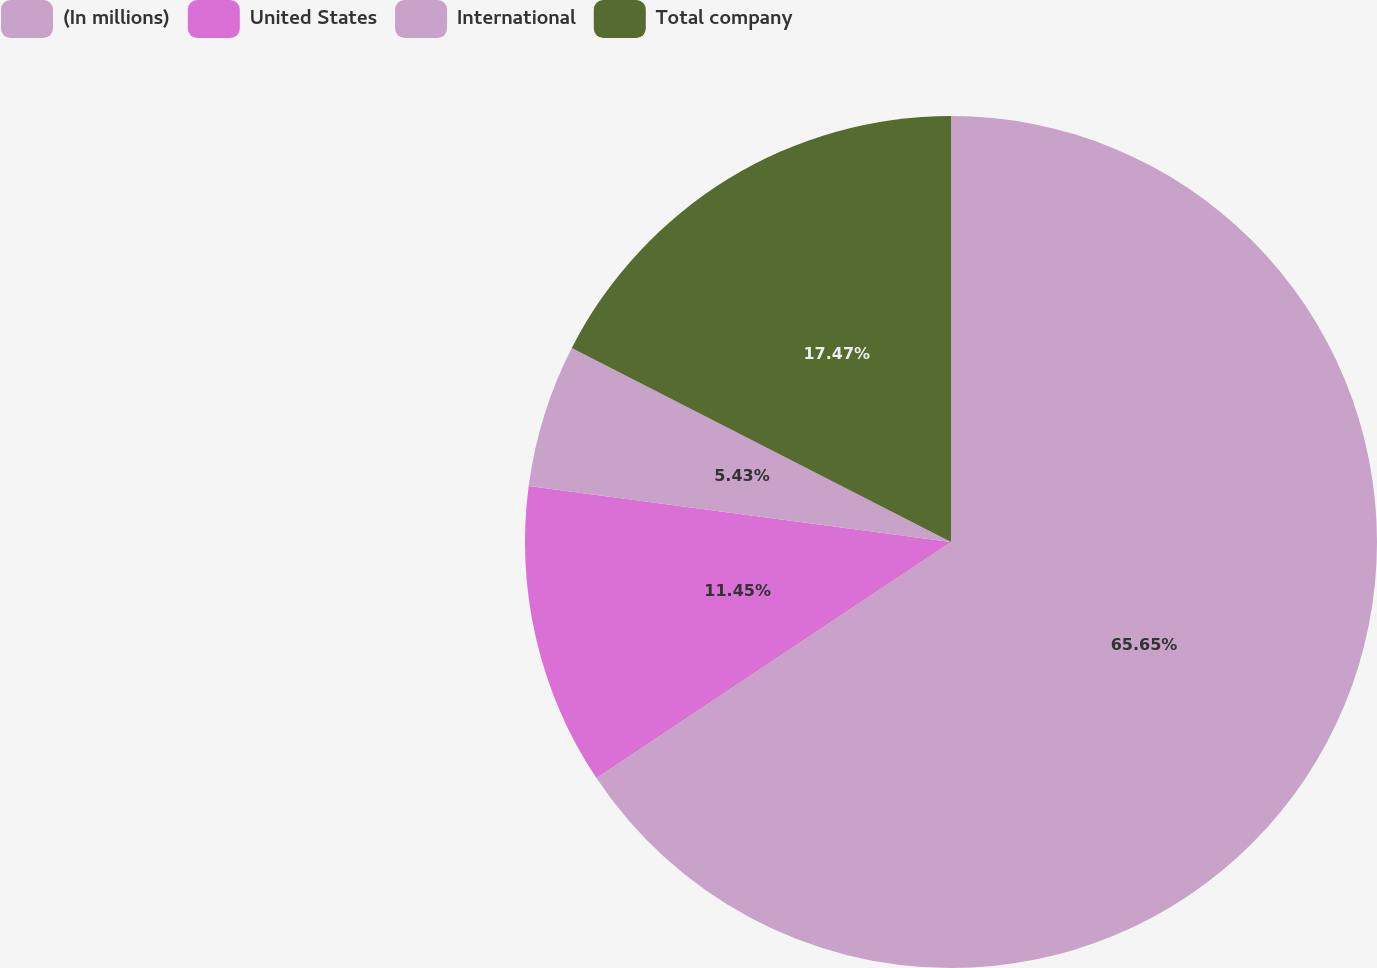Convert chart to OTSL. <chart><loc_0><loc_0><loc_500><loc_500><pie_chart><fcel>(In millions)<fcel>United States<fcel>International<fcel>Total company<nl><fcel>65.65%<fcel>11.45%<fcel>5.43%<fcel>17.47%<nl></chart> 